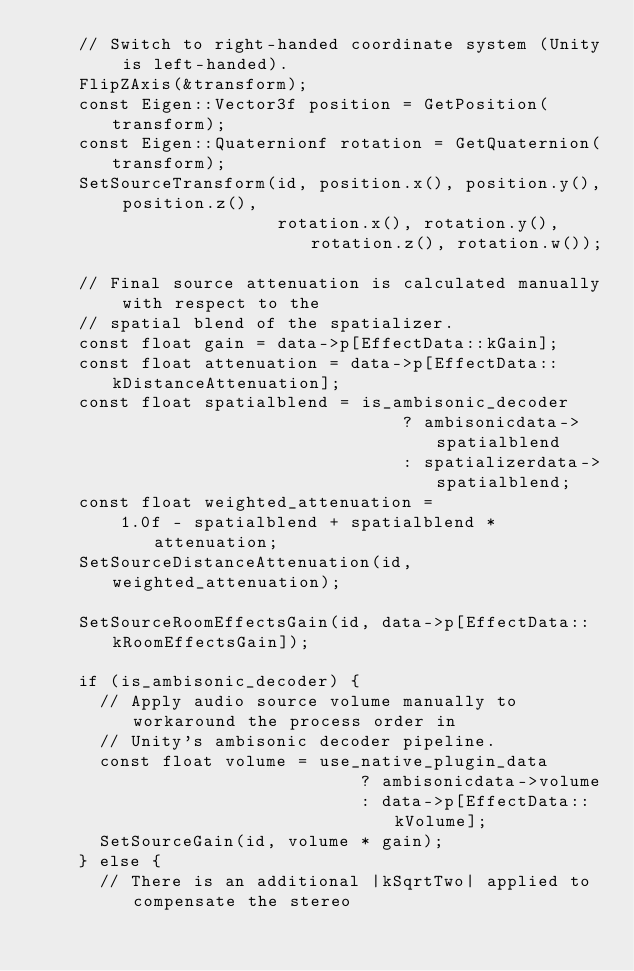Convert code to text. <code><loc_0><loc_0><loc_500><loc_500><_C++_>    // Switch to right-handed coordinate system (Unity is left-handed).
    FlipZAxis(&transform);
    const Eigen::Vector3f position = GetPosition(transform);
    const Eigen::Quaternionf rotation = GetQuaternion(transform);
    SetSourceTransform(id, position.x(), position.y(), position.z(),
                       rotation.x(), rotation.y(), rotation.z(), rotation.w());

    // Final source attenuation is calculated manually with respect to the
    // spatial blend of the spatializer.
    const float gain = data->p[EffectData::kGain];
    const float attenuation = data->p[EffectData::kDistanceAttenuation];
    const float spatialblend = is_ambisonic_decoder
                                   ? ambisonicdata->spatialblend
                                   : spatializerdata->spatialblend;
    const float weighted_attenuation =
        1.0f - spatialblend + spatialblend * attenuation;
    SetSourceDistanceAttenuation(id, weighted_attenuation);

    SetSourceRoomEffectsGain(id, data->p[EffectData::kRoomEffectsGain]);

    if (is_ambisonic_decoder) {
      // Apply audio source volume manually to workaround the process order in
      // Unity's ambisonic decoder pipeline.
      const float volume = use_native_plugin_data
                               ? ambisonicdata->volume
                               : data->p[EffectData::kVolume];
      SetSourceGain(id, volume * gain);
    } else {
      // There is an additional |kSqrtTwo| applied to compensate the stereo</code> 